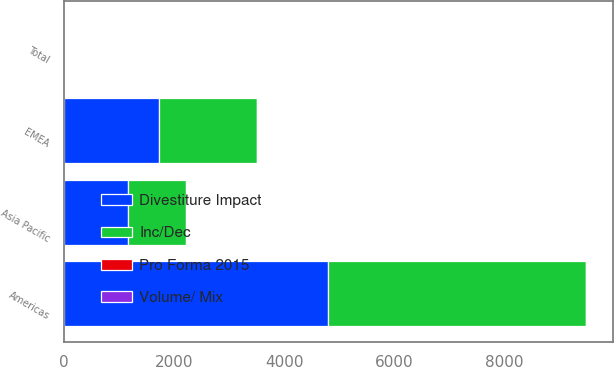<chart> <loc_0><loc_0><loc_500><loc_500><stacked_bar_chart><ecel><fcel>Americas<fcel>EMEA<fcel>Asia Pacific<fcel>Total<nl><fcel>Divestiture Impact<fcel>4802.2<fcel>1730.4<fcel>1151.3<fcel>8.05<nl><fcel>Inc/Dec<fcel>4685.2<fcel>1767.9<fcel>1064.7<fcel>8.05<nl><fcel>Volume/ Mix<fcel>2.5<fcel>2.1<fcel>8.1<fcel>2.2<nl><fcel>Pro Forma 2015<fcel>5.2<fcel>1.9<fcel>8<fcel>4.9<nl></chart> 